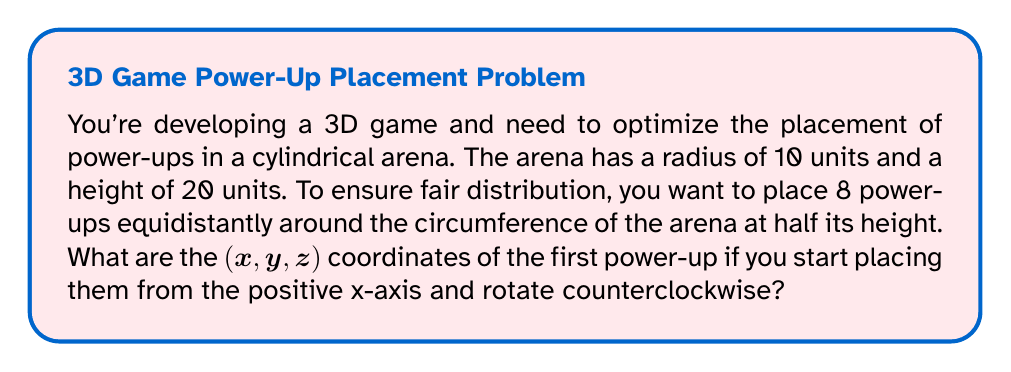Can you answer this question? Let's approach this step-by-step:

1) The power-ups are placed at half the height of the arena:
   $z = 20 / 2 = 10$ units

2) The power-ups are placed on the circumference, so they'll always be 10 units away from the center in the xy-plane.

3) To distribute 8 power-ups evenly, we need to divide the circle into 8 equal parts. Each part will span an angle of:
   $\theta = 360° / 8 = 45°$

4) The first power-up is placed on the positive x-axis, so its angle from the x-axis is 0°.

5) In a circle, the x and y coordinates can be found using:
   $x = r \cos(\theta)$
   $y = r \sin(\theta)$

   Where $r$ is the radius, and $\theta$ is the angle in radians.

6) For the first power-up, $\theta = 0°$ or 0 radians:
   $x = 10 \cos(0) = 10$
   $y = 10 \sin(0) = 0$

7) Therefore, the coordinates of the first power-up are:
   $(x, y, z) = (10, 0, 10)$

[asy]
import graph3;
size(200);
currentprojection=perspective(6,3,2);
draw(cylinder((0,0,0),10,20),blue+opacity(0.1));
dot((10,0,10),red);
label("(10,0,10)",(10,0,10),E);
[/asy]
Answer: $(10, 0, 10)$ 